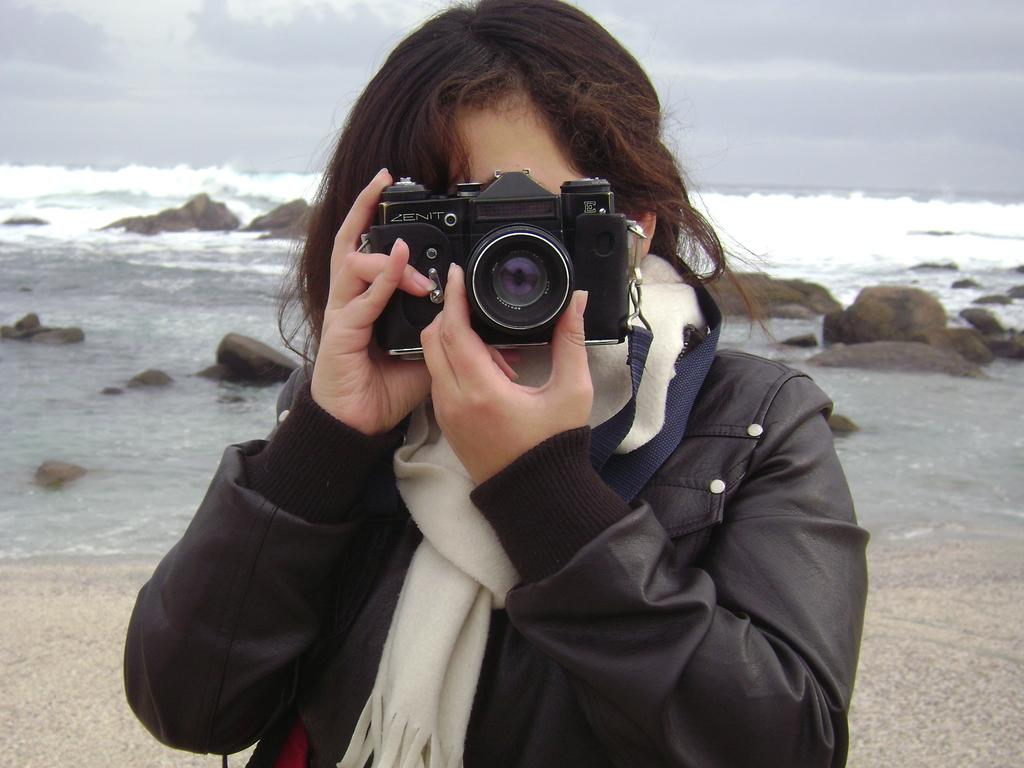Who is present in the image? There is a woman in the image. What is the woman doing in the image? The woman is capturing a picture. What type of landscape can be seen in the image? There are stones and water visible in the image. What else is visible in the image besides the landscape? The sky is visible in the image. What type of basketball game is being played in the image? There is no basketball game present in the image. How does the woman's health affect her ability to capture a picture in the image? The image does not provide any information about the woman's health, so we cannot determine how it might affect her ability to capture a picture. 